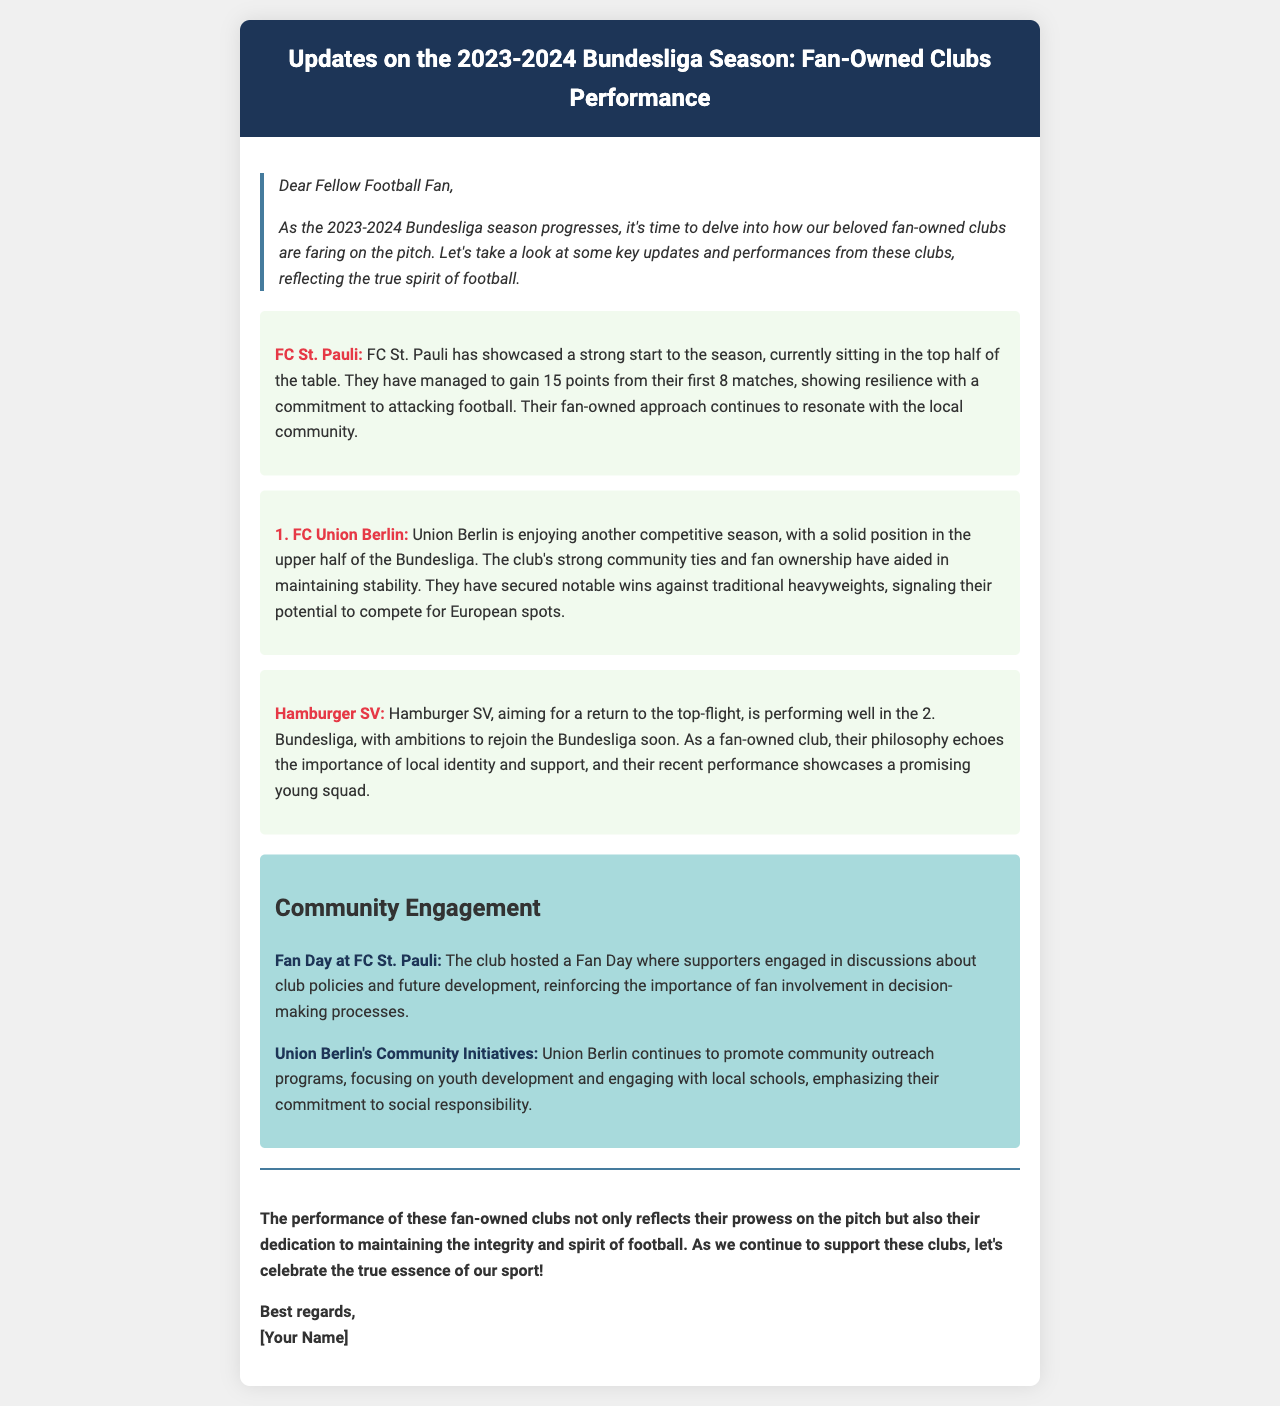What position is FC St. Pauli currently in? The document states that FC St. Pauli is sitting in the top half of the table.
Answer: Top half How many points does FC St. Pauli have? FC St. Pauli has gained 15 points from their first 8 matches.
Answer: 15 points Which clubs are mentioned as fan-owned in the document? The document mentions FC St. Pauli, 1. FC Union Berlin, and Hamburger SV as fan-owned clubs.
Answer: FC St. Pauli, 1. FC Union Berlin, Hamburger SV What notable win does Union Berlin have? The document indicates that Union Berlin has secured notable wins against traditional heavyweights.
Answer: Traditional heavyweights What event did FC St. Pauli host? The document mentions that FC St. Pauli hosted a Fan Day.
Answer: Fan Day What is Hamburger SV's ambition? Hamburger SV aims for a return to the top-flight.
Answer: Return to the top-flight What is a key focus of Union Berlin's community initiatives? The document notes that Union Berlin focuses on youth development in their community initiatives.
Answer: Youth development What is the significance of fan involvement according to the document? The document emphasizes the importance of fan involvement in decision-making processes.
Answer: Importance of fan involvement 